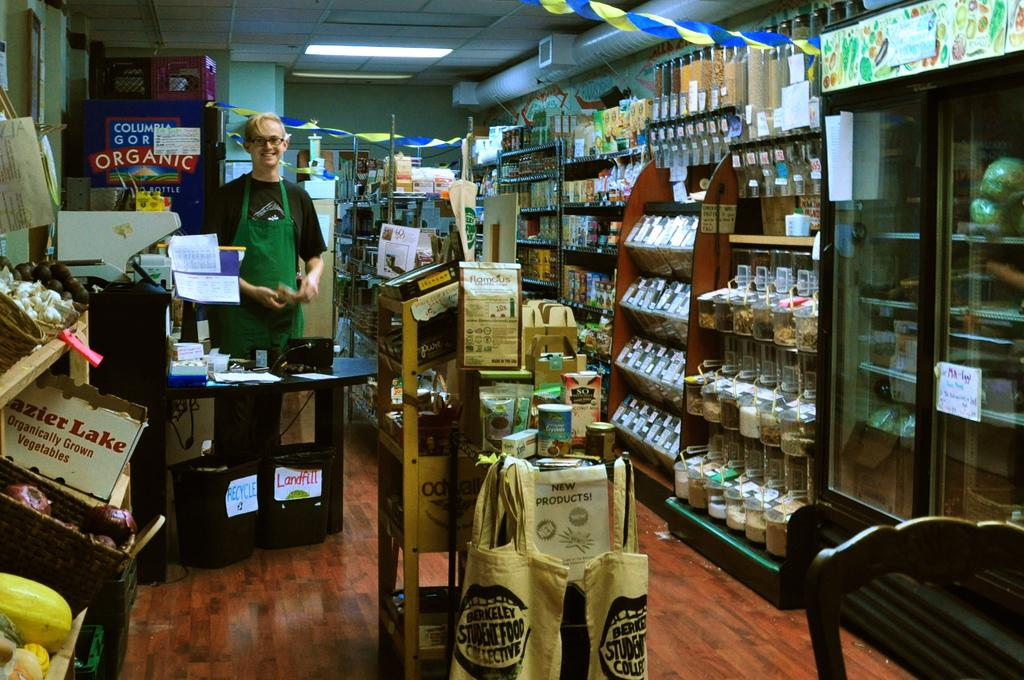<image>
Share a concise interpretation of the image provided. A man standing in a store that has an advertisement for new products 